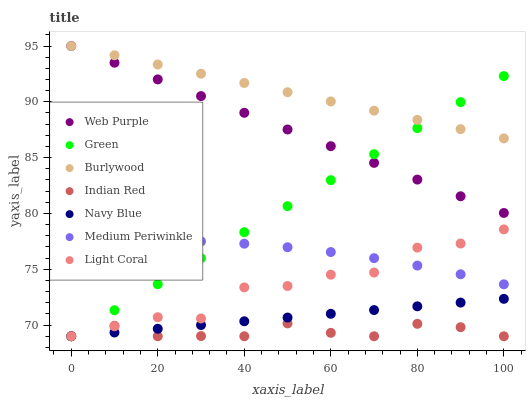Does Indian Red have the minimum area under the curve?
Answer yes or no. Yes. Does Burlywood have the maximum area under the curve?
Answer yes or no. Yes. Does Navy Blue have the minimum area under the curve?
Answer yes or no. No. Does Navy Blue have the maximum area under the curve?
Answer yes or no. No. Is Burlywood the smoothest?
Answer yes or no. Yes. Is Light Coral the roughest?
Answer yes or no. Yes. Is Navy Blue the smoothest?
Answer yes or no. No. Is Navy Blue the roughest?
Answer yes or no. No. Does Navy Blue have the lowest value?
Answer yes or no. Yes. Does Medium Periwinkle have the lowest value?
Answer yes or no. No. Does Web Purple have the highest value?
Answer yes or no. Yes. Does Navy Blue have the highest value?
Answer yes or no. No. Is Medium Periwinkle less than Web Purple?
Answer yes or no. Yes. Is Web Purple greater than Light Coral?
Answer yes or no. Yes. Does Indian Red intersect Navy Blue?
Answer yes or no. Yes. Is Indian Red less than Navy Blue?
Answer yes or no. No. Is Indian Red greater than Navy Blue?
Answer yes or no. No. Does Medium Periwinkle intersect Web Purple?
Answer yes or no. No. 